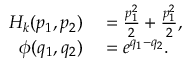Convert formula to latex. <formula><loc_0><loc_0><loc_500><loc_500>\begin{array} { r l } { H _ { k } ( p _ { 1 } , p _ { 2 } ) } & = \frac { p _ { 1 } ^ { 2 } } { 2 } + \frac { p _ { 1 } ^ { 2 } } { 2 } , } \\ { \phi ( q _ { 1 } , q _ { 2 } ) } & = e ^ { q _ { 1 } - q _ { 2 } } . } \end{array}</formula> 